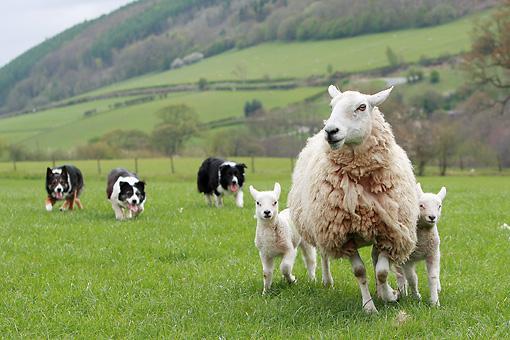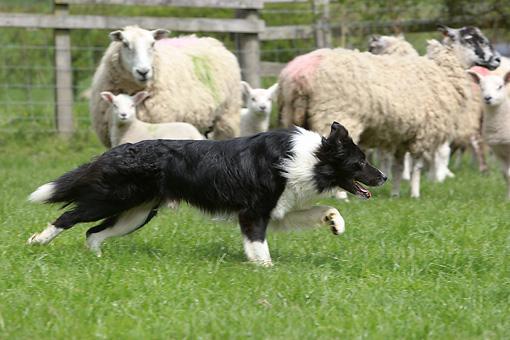The first image is the image on the left, the second image is the image on the right. Assess this claim about the two images: "Colored dye is visible on sheep's wool in the right image.". Correct or not? Answer yes or no. Yes. The first image is the image on the left, the second image is the image on the right. Evaluate the accuracy of this statement regarding the images: "There are at least two dogs in the image on the left.". Is it true? Answer yes or no. Yes. 